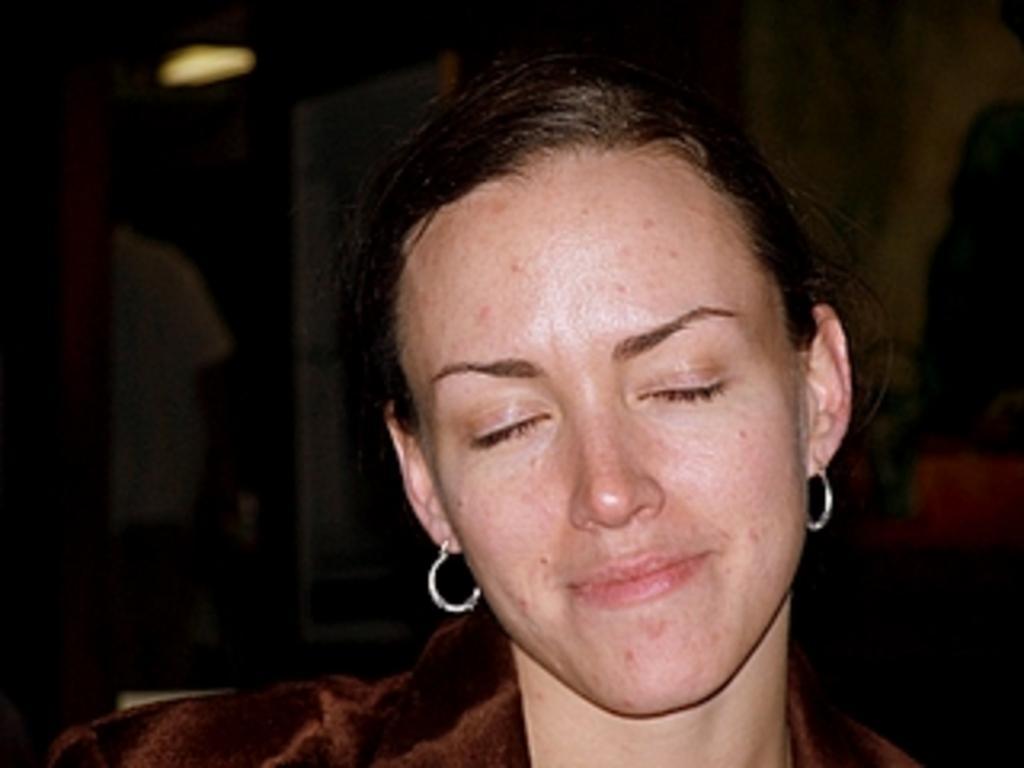Could you give a brief overview of what you see in this image? As we can see in the image there is a woman sitting on chair, light and a wall. The background is dark. 